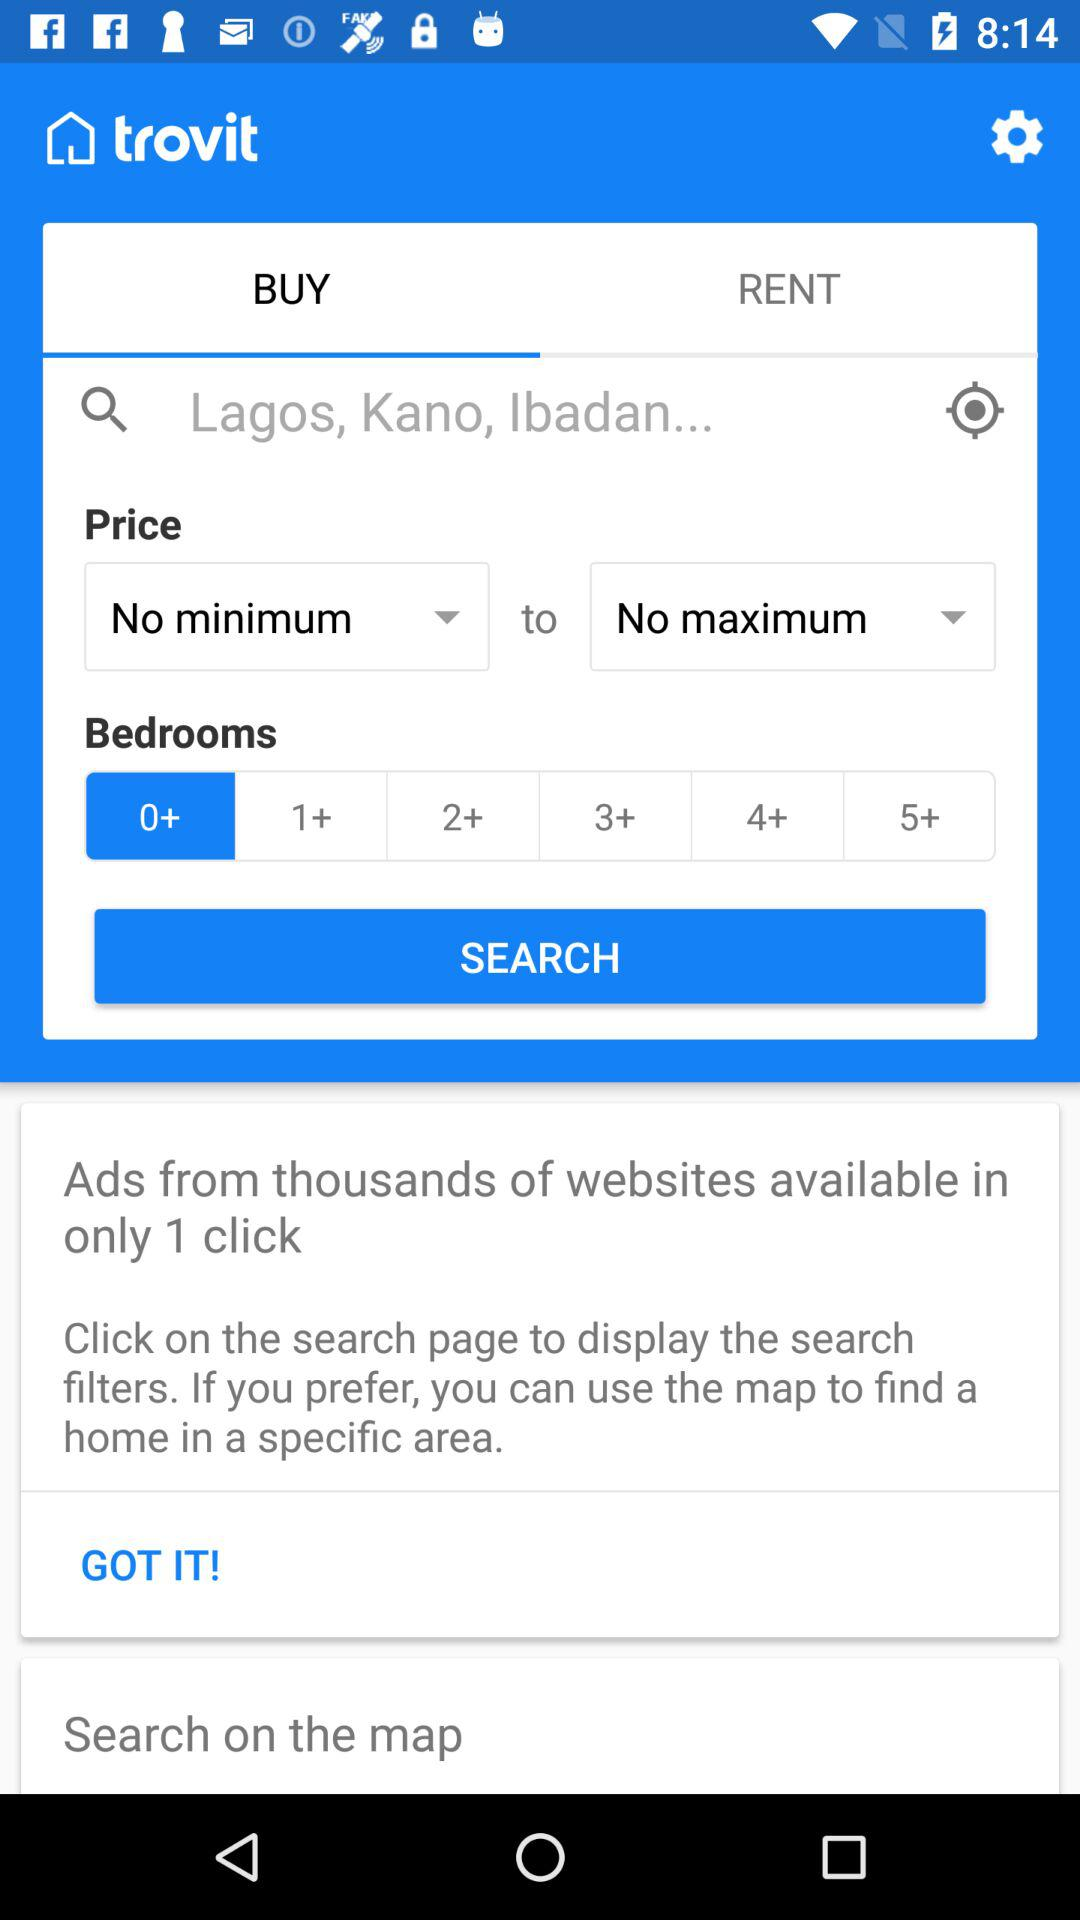What are the options available for bedrooms? The available options for bedrooms are "0+", "1+", "2+", "3+", "4+" and "5+". 